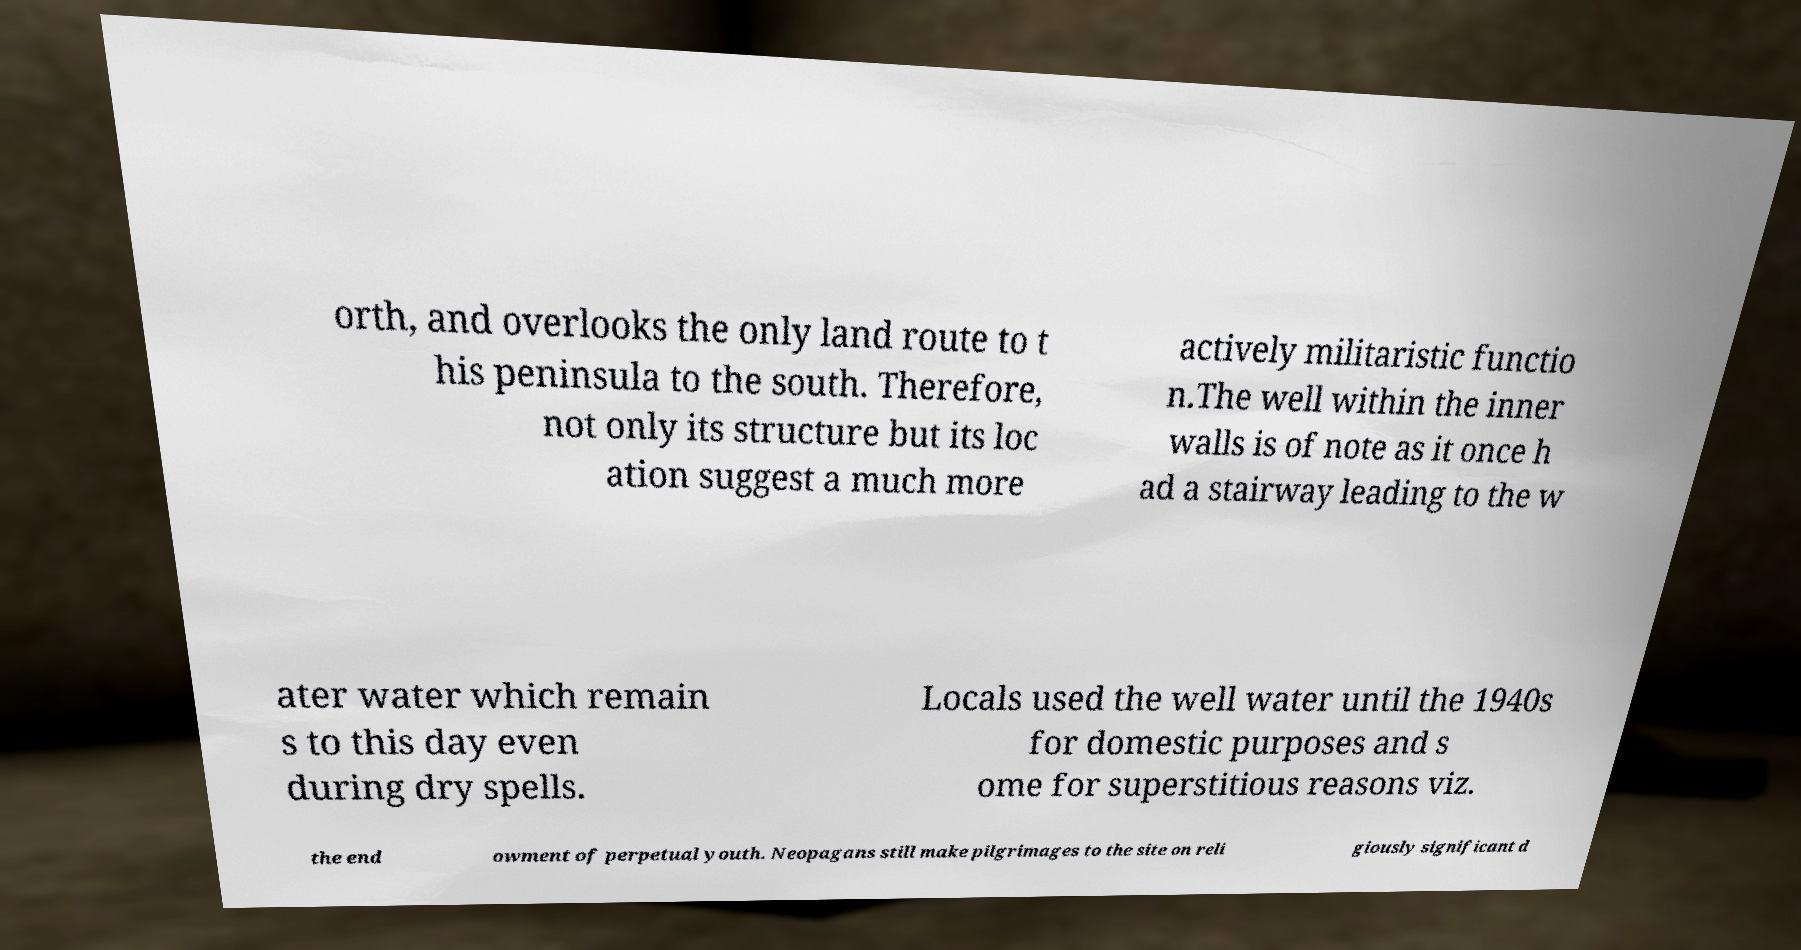I need the written content from this picture converted into text. Can you do that? orth, and overlooks the only land route to t his peninsula to the south. Therefore, not only its structure but its loc ation suggest a much more actively militaristic functio n.The well within the inner walls is of note as it once h ad a stairway leading to the w ater water which remain s to this day even during dry spells. Locals used the well water until the 1940s for domestic purposes and s ome for superstitious reasons viz. the end owment of perpetual youth. Neopagans still make pilgrimages to the site on reli giously significant d 